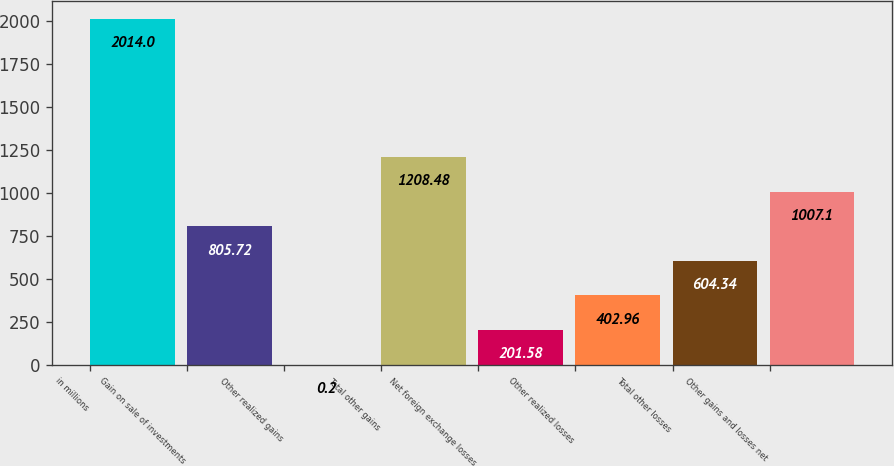<chart> <loc_0><loc_0><loc_500><loc_500><bar_chart><fcel>in millions<fcel>Gain on sale of investments<fcel>Other realized gains<fcel>Total other gains<fcel>Net foreign exchange losses<fcel>Other realized losses<fcel>Total other losses<fcel>Other gains and losses net<nl><fcel>2014<fcel>805.72<fcel>0.2<fcel>1208.48<fcel>201.58<fcel>402.96<fcel>604.34<fcel>1007.1<nl></chart> 